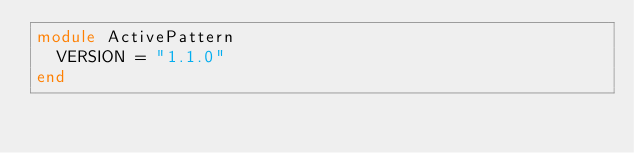<code> <loc_0><loc_0><loc_500><loc_500><_Ruby_>module ActivePattern
  VERSION = "1.1.0"
end
</code> 